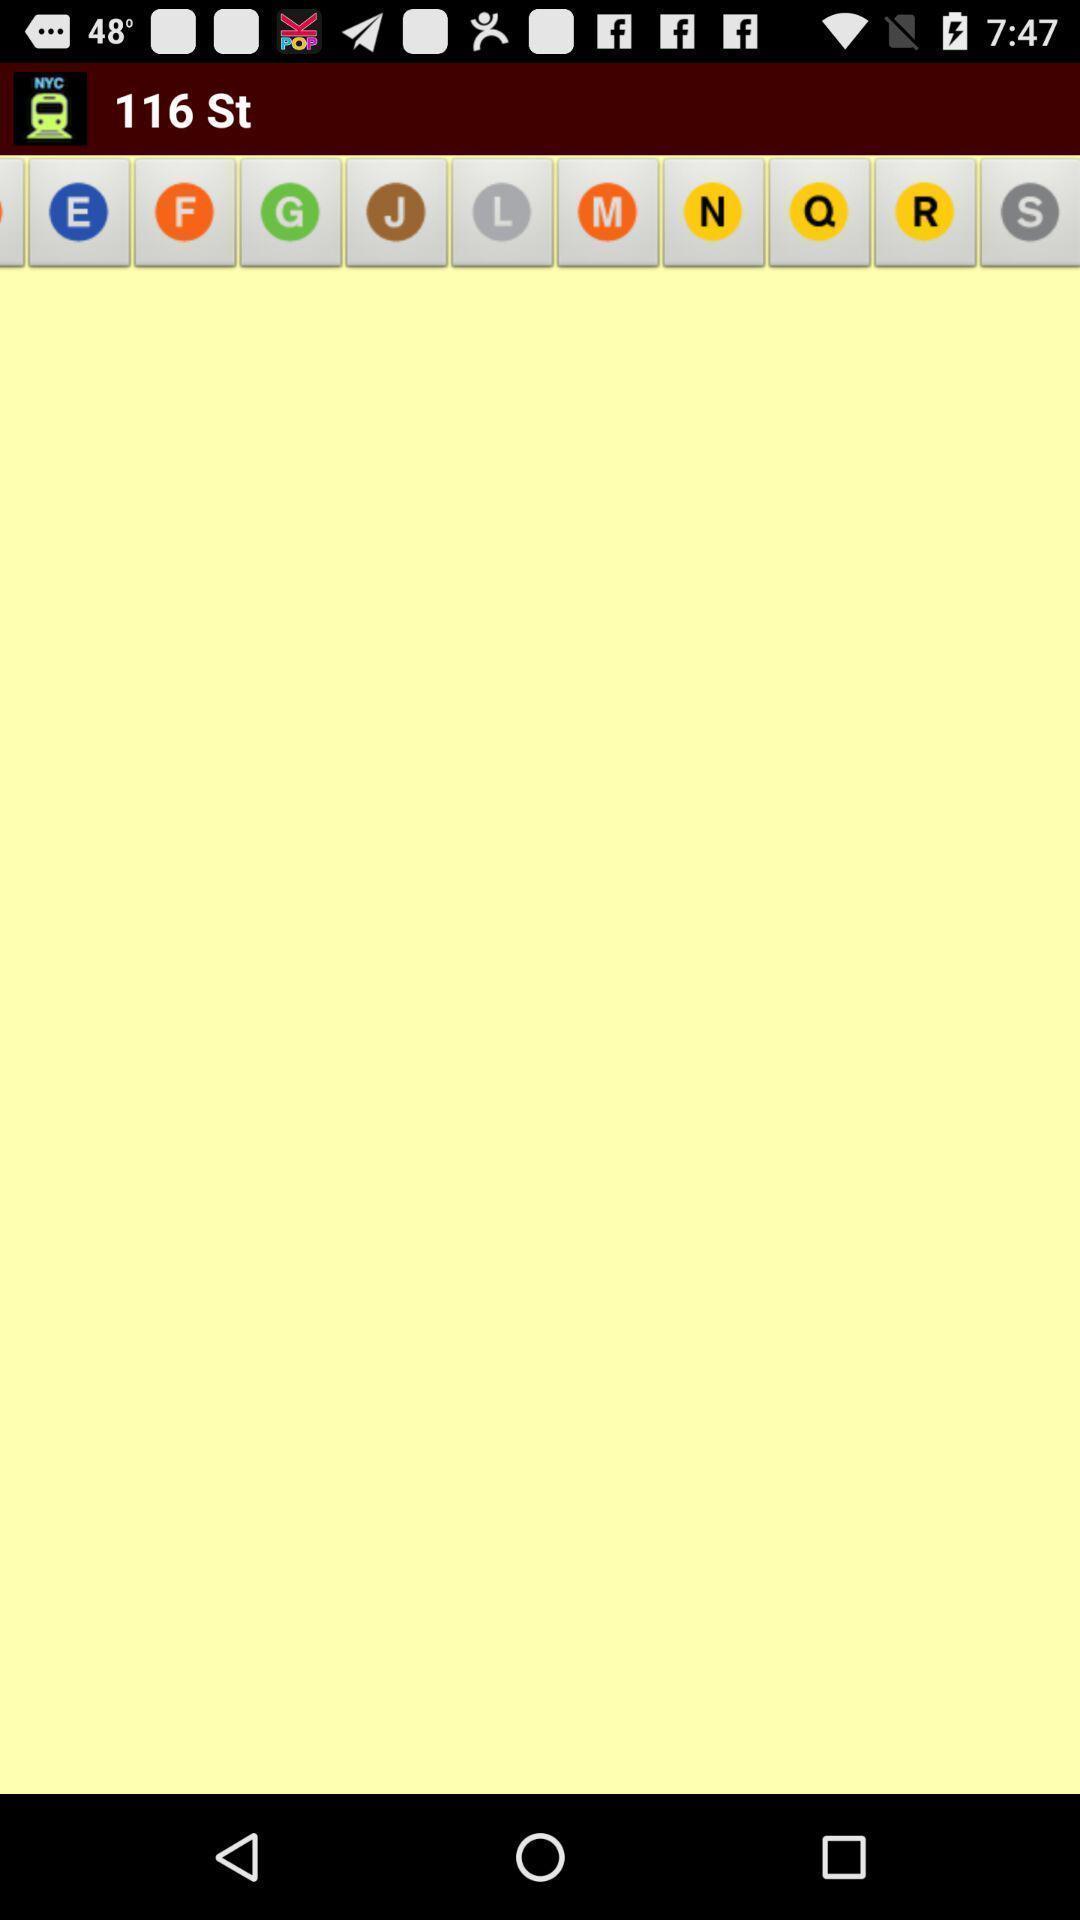What details can you identify in this image? Page showing different options on an app. 